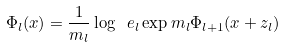Convert formula to latex. <formula><loc_0><loc_0><loc_500><loc_500>\Phi _ { l } ( x ) = \frac { 1 } { m _ { l } } \log \ e _ { l } \exp m _ { l } \Phi _ { l + 1 } ( x + z _ { l } )</formula> 